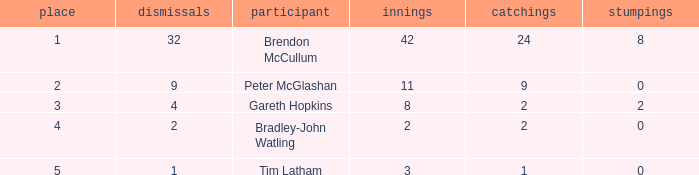How many stumpings did the player Tim Latham have? 0.0. 